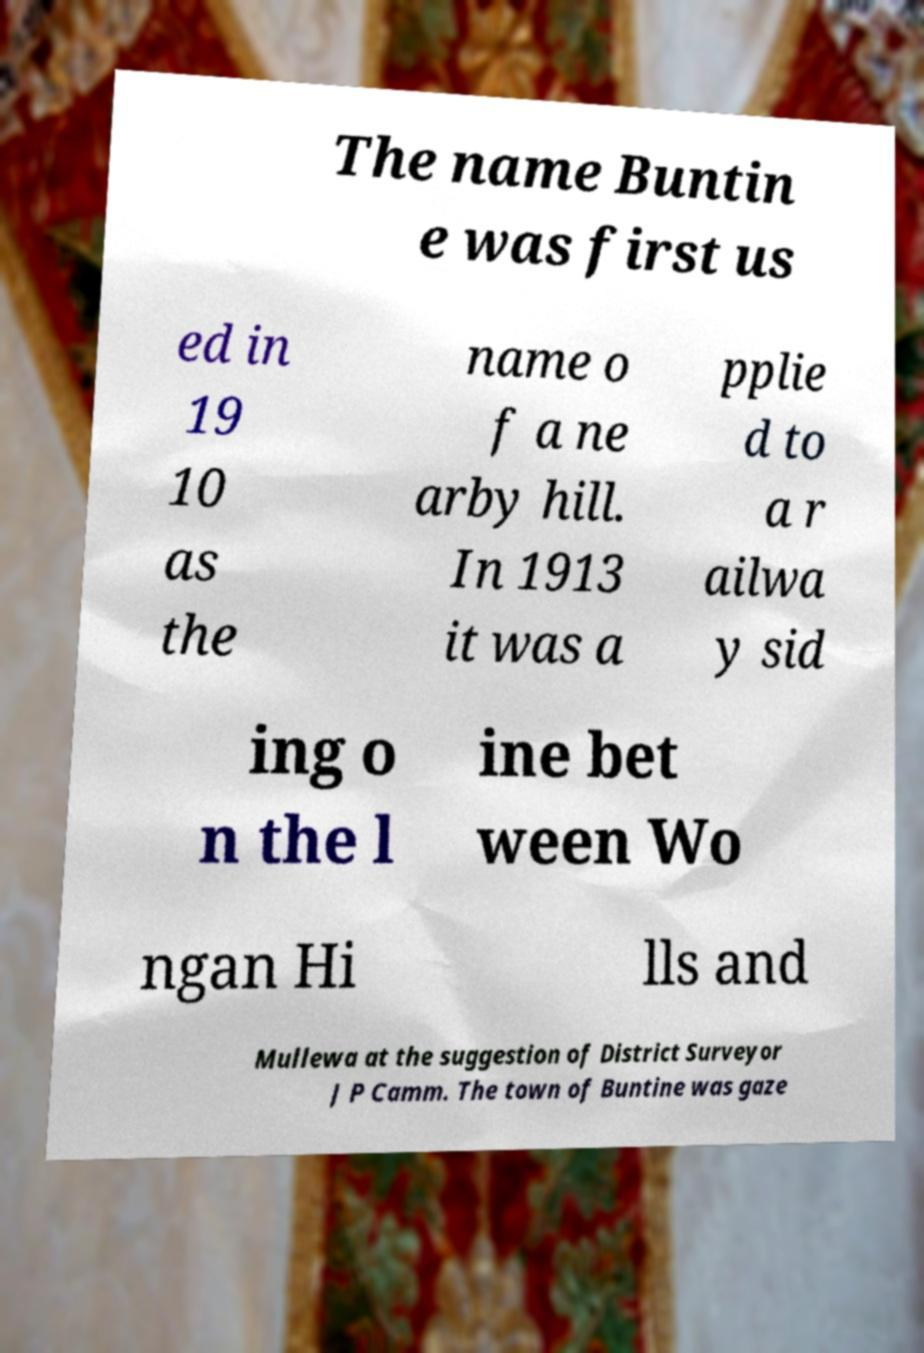I need the written content from this picture converted into text. Can you do that? The name Buntin e was first us ed in 19 10 as the name o f a ne arby hill. In 1913 it was a pplie d to a r ailwa y sid ing o n the l ine bet ween Wo ngan Hi lls and Mullewa at the suggestion of District Surveyor J P Camm. The town of Buntine was gaze 